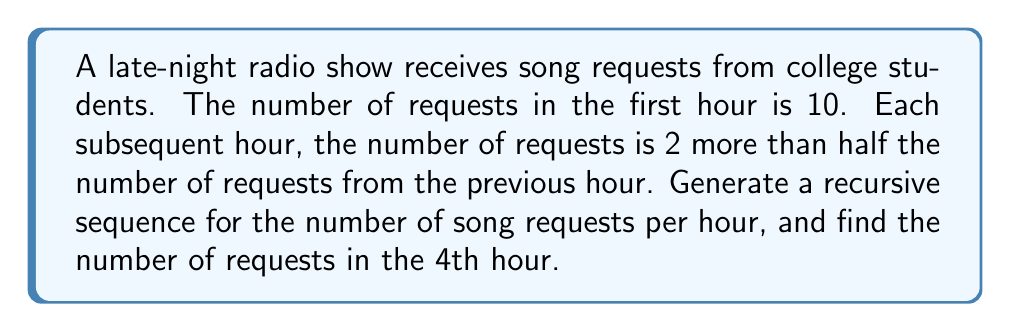What is the answer to this math problem? Let's approach this step-by-step:

1) Let $a_n$ represent the number of requests in the nth hour.

2) We're given that $a_1 = 10$ (10 requests in the first hour).

3) For subsequent hours, we can express the recursive relation as:

   $a_{n+1} = \frac{a_n}{2} + 2$ for $n \geq 1$

4) Now, let's calculate the values for the first 4 hours:

   Hour 1: $a_1 = 10$

   Hour 2: $a_2 = \frac{a_1}{2} + 2 = \frac{10}{2} + 2 = 5 + 2 = 7$

   Hour 3: $a_3 = \frac{a_2}{2} + 2 = \frac{7}{2} + 2 = 3.5 + 2 = 5.5$

   Hour 4: $a_4 = \frac{a_3}{2} + 2 = \frac{5.5}{2} + 2 = 2.75 + 2 = 4.75$

5) Therefore, in the 4th hour, there will be 4.75 requests.
Answer: $a_n = \begin{cases} 10 & \text{if } n = 1 \\ \frac{a_{n-1}}{2} + 2 & \text{if } n > 1 \end{cases}$; $a_4 = 4.75$ 